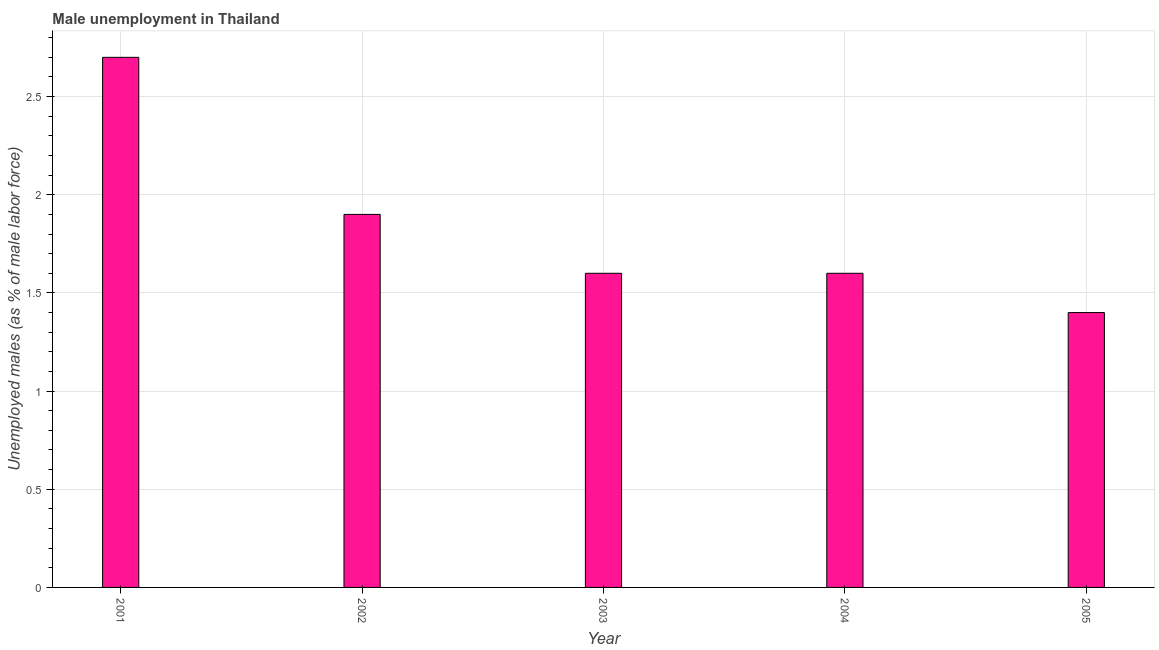Does the graph contain any zero values?
Your answer should be very brief. No. What is the title of the graph?
Provide a succinct answer. Male unemployment in Thailand. What is the label or title of the Y-axis?
Your answer should be very brief. Unemployed males (as % of male labor force). What is the unemployed males population in 2004?
Your answer should be compact. 1.6. Across all years, what is the maximum unemployed males population?
Your response must be concise. 2.7. Across all years, what is the minimum unemployed males population?
Offer a terse response. 1.4. In which year was the unemployed males population maximum?
Make the answer very short. 2001. In which year was the unemployed males population minimum?
Offer a terse response. 2005. What is the sum of the unemployed males population?
Your answer should be compact. 9.2. What is the difference between the unemployed males population in 2001 and 2005?
Provide a short and direct response. 1.3. What is the average unemployed males population per year?
Your response must be concise. 1.84. What is the median unemployed males population?
Give a very brief answer. 1.6. In how many years, is the unemployed males population greater than 1.8 %?
Ensure brevity in your answer.  2. What is the ratio of the unemployed males population in 2004 to that in 2005?
Make the answer very short. 1.14. Is the unemployed males population in 2001 less than that in 2003?
Ensure brevity in your answer.  No. Is the difference between the unemployed males population in 2001 and 2005 greater than the difference between any two years?
Your response must be concise. Yes. What is the difference between the highest and the second highest unemployed males population?
Offer a terse response. 0.8. In how many years, is the unemployed males population greater than the average unemployed males population taken over all years?
Provide a succinct answer. 2. Are all the bars in the graph horizontal?
Give a very brief answer. No. What is the difference between two consecutive major ticks on the Y-axis?
Give a very brief answer. 0.5. What is the Unemployed males (as % of male labor force) in 2001?
Offer a very short reply. 2.7. What is the Unemployed males (as % of male labor force) in 2002?
Ensure brevity in your answer.  1.9. What is the Unemployed males (as % of male labor force) of 2003?
Offer a terse response. 1.6. What is the Unemployed males (as % of male labor force) in 2004?
Offer a very short reply. 1.6. What is the Unemployed males (as % of male labor force) of 2005?
Provide a short and direct response. 1.4. What is the difference between the Unemployed males (as % of male labor force) in 2001 and 2004?
Your answer should be compact. 1.1. What is the difference between the Unemployed males (as % of male labor force) in 2002 and 2003?
Provide a succinct answer. 0.3. What is the difference between the Unemployed males (as % of male labor force) in 2002 and 2005?
Ensure brevity in your answer.  0.5. What is the difference between the Unemployed males (as % of male labor force) in 2003 and 2004?
Provide a short and direct response. 0. What is the difference between the Unemployed males (as % of male labor force) in 2003 and 2005?
Your response must be concise. 0.2. What is the difference between the Unemployed males (as % of male labor force) in 2004 and 2005?
Offer a very short reply. 0.2. What is the ratio of the Unemployed males (as % of male labor force) in 2001 to that in 2002?
Give a very brief answer. 1.42. What is the ratio of the Unemployed males (as % of male labor force) in 2001 to that in 2003?
Make the answer very short. 1.69. What is the ratio of the Unemployed males (as % of male labor force) in 2001 to that in 2004?
Keep it short and to the point. 1.69. What is the ratio of the Unemployed males (as % of male labor force) in 2001 to that in 2005?
Offer a terse response. 1.93. What is the ratio of the Unemployed males (as % of male labor force) in 2002 to that in 2003?
Your answer should be very brief. 1.19. What is the ratio of the Unemployed males (as % of male labor force) in 2002 to that in 2004?
Provide a short and direct response. 1.19. What is the ratio of the Unemployed males (as % of male labor force) in 2002 to that in 2005?
Keep it short and to the point. 1.36. What is the ratio of the Unemployed males (as % of male labor force) in 2003 to that in 2004?
Make the answer very short. 1. What is the ratio of the Unemployed males (as % of male labor force) in 2003 to that in 2005?
Your answer should be compact. 1.14. What is the ratio of the Unemployed males (as % of male labor force) in 2004 to that in 2005?
Your answer should be very brief. 1.14. 